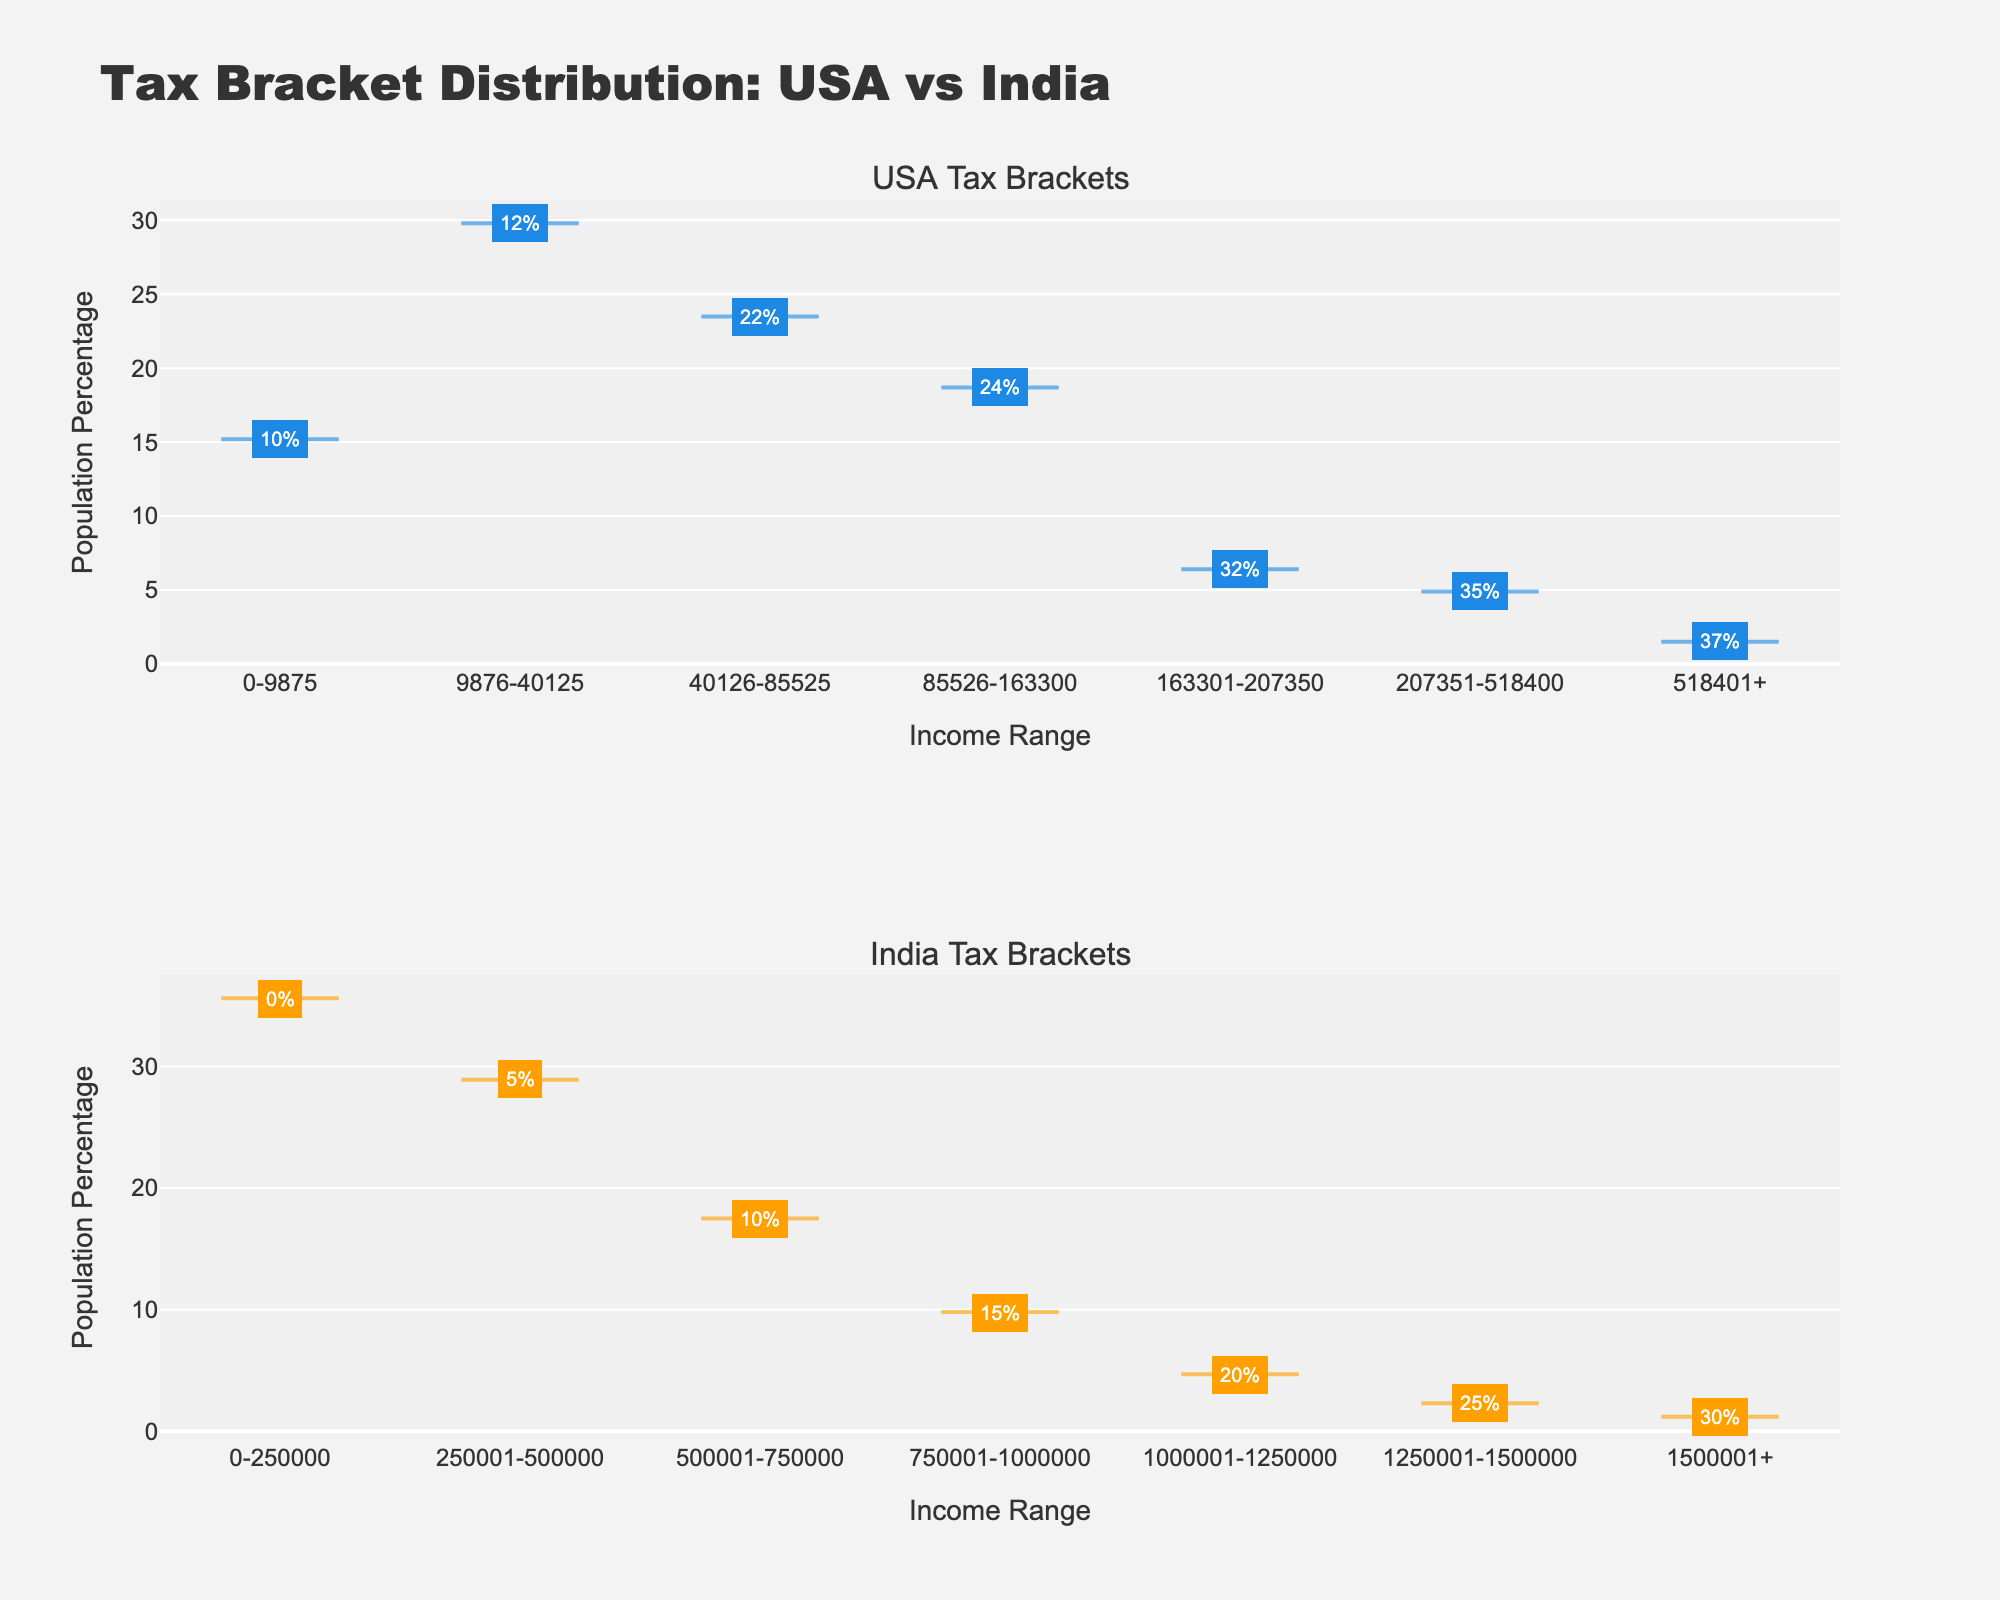What is the title of the plot? The title is displayed at the top of the figure and reads "Tax Bracket Distribution: USA vs India."
Answer: Tax Bracket Distribution: USA vs India What are the labels of the x-axes in the subplots? Both x-axes labels are titled "Income Range," which is marked at the bottom of each subplot.
Answer: Income Range What are the labels of the y-axes in the subplots? Both y-axes labels are titled "Population Percentage," which is marked along the left side of each subplot.
Answer: Population Percentage Which country has the highest population percentage in the lowest income range? The lowest income range for the USA (0-9875) has a population percentage of 15.2%, whereas India (0-250000) has a percentage of 35.6%.
Answer: India Which tax bracket has the highest population percentage in the USA? The income range 9876-40125 has a population percentage of 29.8% in the USA, as shown in the plot.
Answer: 9876-40125 What is the tax rate for the highest income range in India? By looking at the annotations in the second subplot for India, the highest income range (1500001+) has a tax rate of 30%.
Answer: 30% How does the distribution of population percentages compare between the two countries for the highest tax bracket? In the highest income range, USA (518401+) has a population percentage of 1.5%, whereas India (1500001+) has a population percentage of 1.2%.
Answer: USA has a higher population percentage What is the combined population percentage for the first two income ranges in India? In India, the first income range (0-250000) has 35.6% and the second range (250001-500000) has 28.9%. Adding these together gives 35.6 + 28.9 = 64.5%.
Answer: 64.5% In which income range does the USA have a tax rate of 24%? The 24% tax rate for the USA is annotated in the income range 85526-163300 in the first subplot.
Answer: 85526-163300 Which country has a greater variety of tax rates across income ranges? By counting the number of different tax rates shown in the annotations for each subplot, the USA has 7 different tax rates while India has 7 as well. Both have the same variety.
Answer: Both have the same variety 